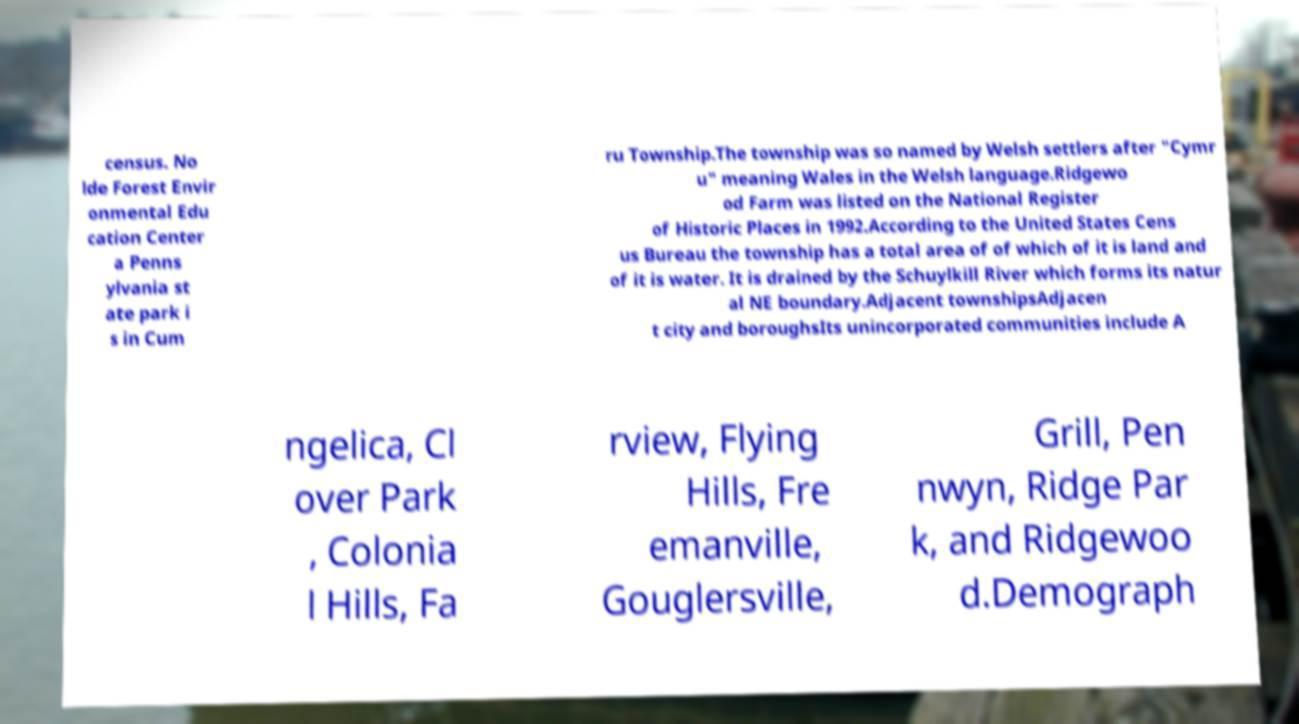Please identify and transcribe the text found in this image. census. No lde Forest Envir onmental Edu cation Center a Penns ylvania st ate park i s in Cum ru Township.The township was so named by Welsh settlers after "Cymr u" meaning Wales in the Welsh language.Ridgewo od Farm was listed on the National Register of Historic Places in 1992.According to the United States Cens us Bureau the township has a total area of of which of it is land and of it is water. It is drained by the Schuylkill River which forms its natur al NE boundary.Adjacent townshipsAdjacen t city and boroughsIts unincorporated communities include A ngelica, Cl over Park , Colonia l Hills, Fa rview, Flying Hills, Fre emanville, Gouglersville, Grill, Pen nwyn, Ridge Par k, and Ridgewoo d.Demograph 